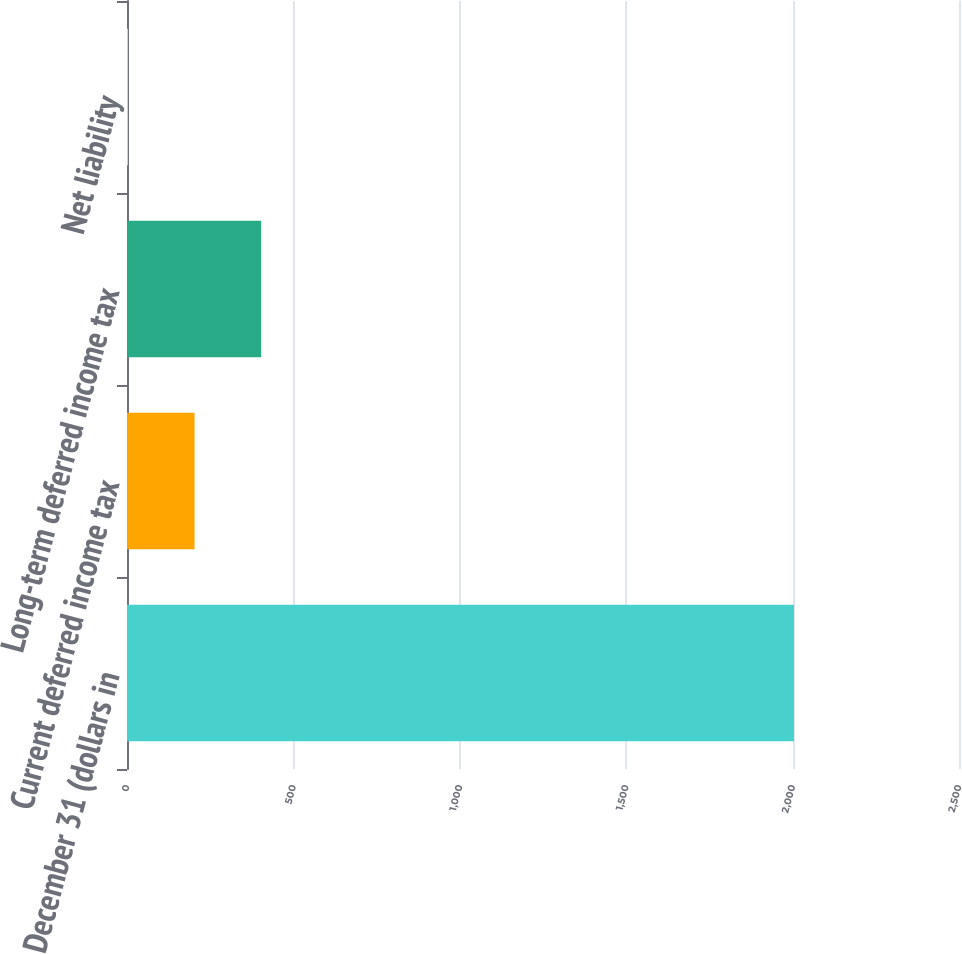Convert chart. <chart><loc_0><loc_0><loc_500><loc_500><bar_chart><fcel>December 31 (dollars in<fcel>Current deferred income tax<fcel>Long-term deferred income tax<fcel>Net liability<nl><fcel>2004<fcel>203.01<fcel>403.12<fcel>2.9<nl></chart> 